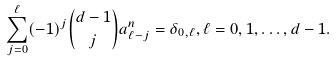<formula> <loc_0><loc_0><loc_500><loc_500>\sum _ { j = 0 } ^ { \ell } ( - 1 ) ^ { j } \binom { d - 1 } { j } a _ { \ell - j } ^ { n } = \delta _ { 0 , \ell } , \ell = 0 , 1 , \dots , d - 1 .</formula> 